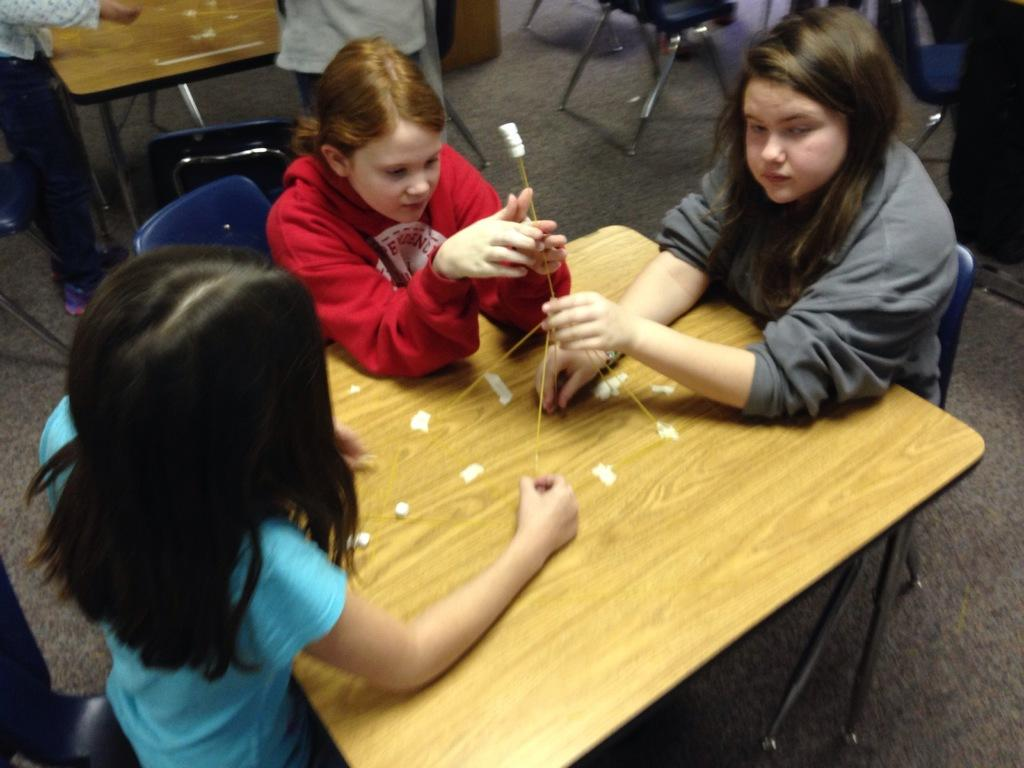How many people are sitting on chairs in the image? There are three people sitting on chairs in the image. What are the people holding in their hands? The people are holding sticks in their hands. Can you describe the presence of other people in the image? Yes, there are other people in the image besides the three sitting on chairs. What is the primary piece of furniture in the image? There is a table in the image. What type of patch can be seen on the ground in the image? There is no patch visible on the ground in the image. 